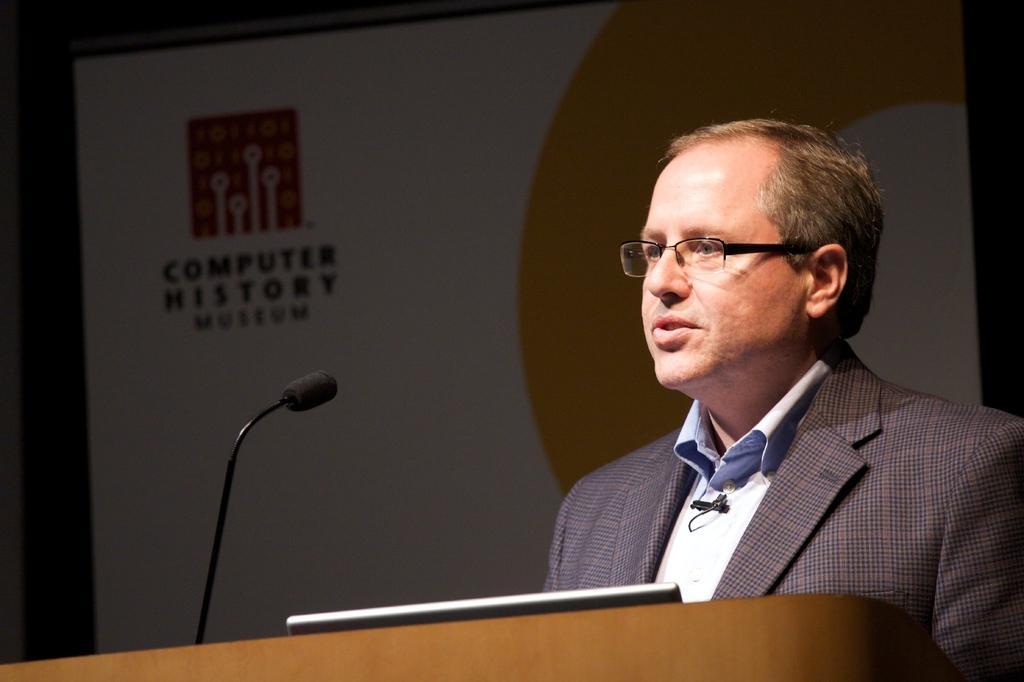In one or two sentences, can you explain what this image depicts? In this picture there is a man who is standing on the right side of the image and there is a desk and a mic in front of him, there is a projector screen in the background area of the image. 